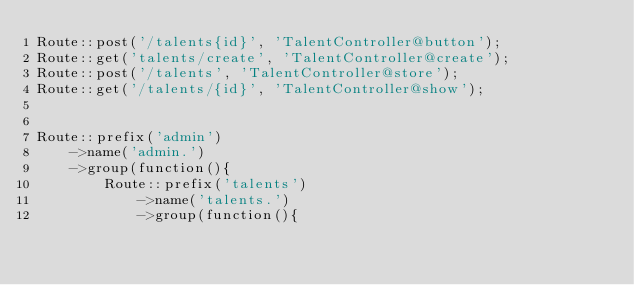<code> <loc_0><loc_0><loc_500><loc_500><_PHP_>Route::post('/talents{id}', 'TalentController@button');
Route::get('talents/create', 'TalentController@create');
Route::post('/talents', 'TalentController@store');
Route::get('/talents/{id}', 'TalentController@show');


Route::prefix('admin')
    ->name('admin.')
    ->group(function(){
        Route::prefix('talents')
            ->name('talents.')
            ->group(function(){</code> 